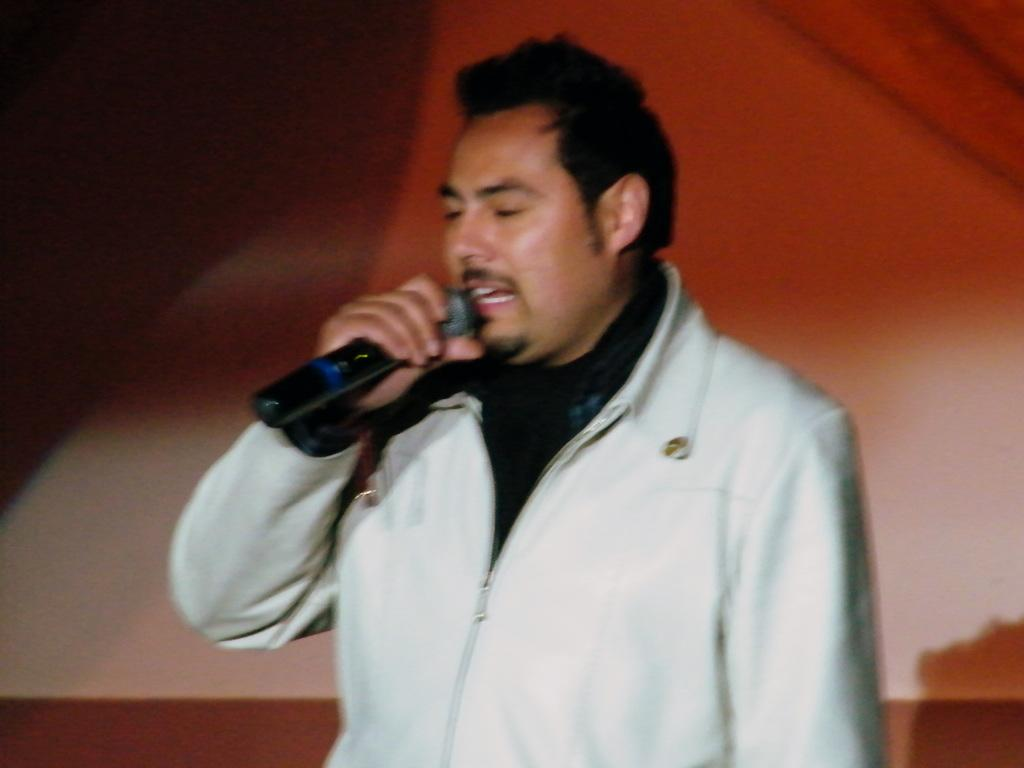What is the person in the image doing? The person is holding a mic in his hand and singing something. What is the person wearing? The person is wearing a white color jacket and a black color t-shirt. Can you describe the person's activity in the image? The person is singing while holding a mic, which suggests he might be performing or giving a speech. What type of road can be seen in the image? There is no road visible in the image; it features a person holding a mic and singing. Who is the manager of the person in the image? The provided facts do not mention a manager, so it cannot be determined from the image. 